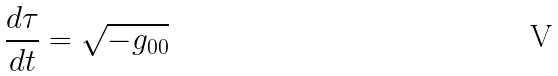<formula> <loc_0><loc_0><loc_500><loc_500>\frac { d \tau } { d t } = \sqrt { - g _ { 0 0 } }</formula> 